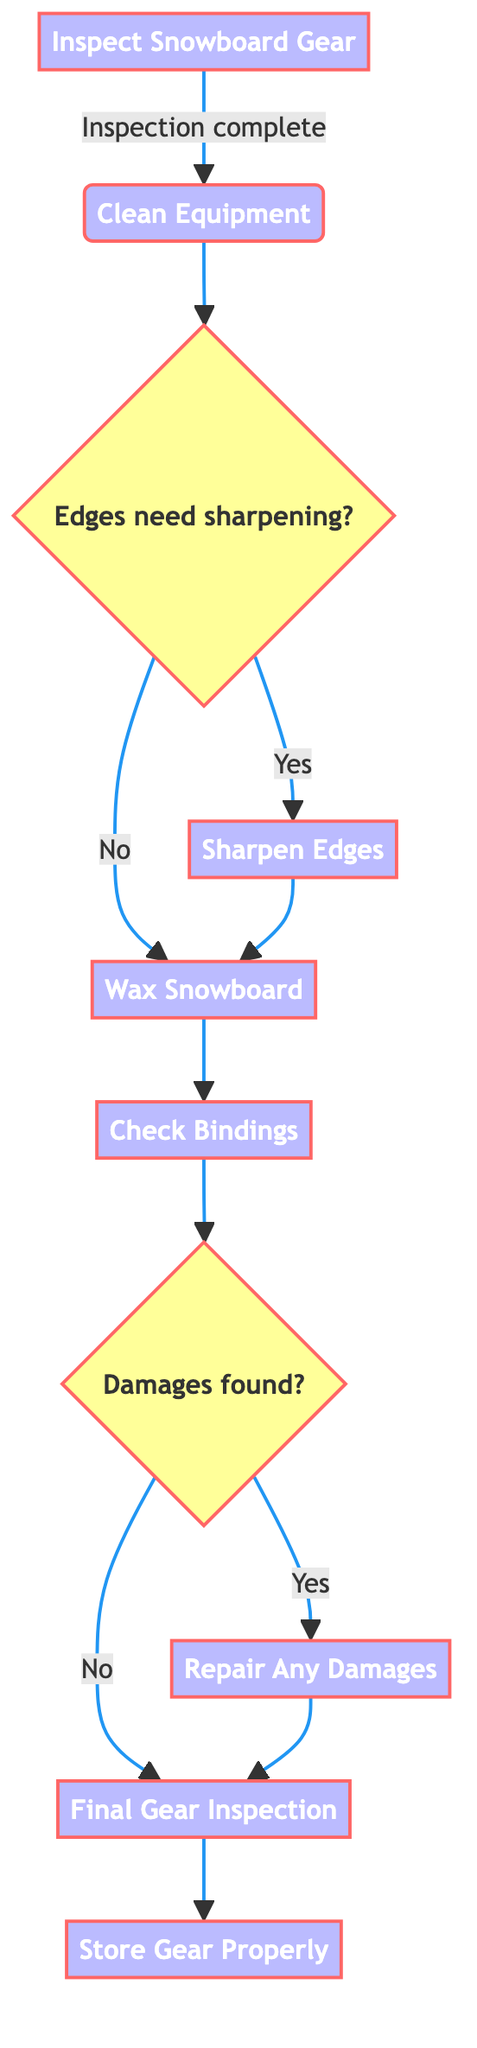What is the first step in the workflow? The first step in the workflow, as shown in the diagram, is "Inspect Snowboard Gear." This is the starting point of the flowchart where the user initiates the maintenance process.
Answer: Inspect Snowboard Gear How many decision points are there in the diagram? The diagram has three decision points identified by the use of curly braces, indicating a choice that must be made at those steps. The specific decision points are related to whether the edges need sharpening and if any damages are found.
Answer: 3 What happens if the edges do not need sharpening? If the edges do not need sharpening, the flow moves directly to the "Wax Snowboard" step, indicating that this maintenance task follows after cleaning the equipment without needing to sharpen the edges.
Answer: Wax Snowboard What is the final step in the equipment maintenance workflow? The final step in the workflow is "Store Gear Properly," which concludes the entire maintenance process, ensuring that the snowboard and equipment are stored correctly.
Answer: Store Gear Properly What is the relationship between "Check Bindings" and "Repair Any Damages"? The "Check Bindings" step leads to a decision point where it is determined if any damages are found. If damages are found, then the flow continues to the "Repair Any Damages" step, establishing a direct connection between those two processes.
Answer: Check Bindings leads to Repair Any Damages if damages are found 